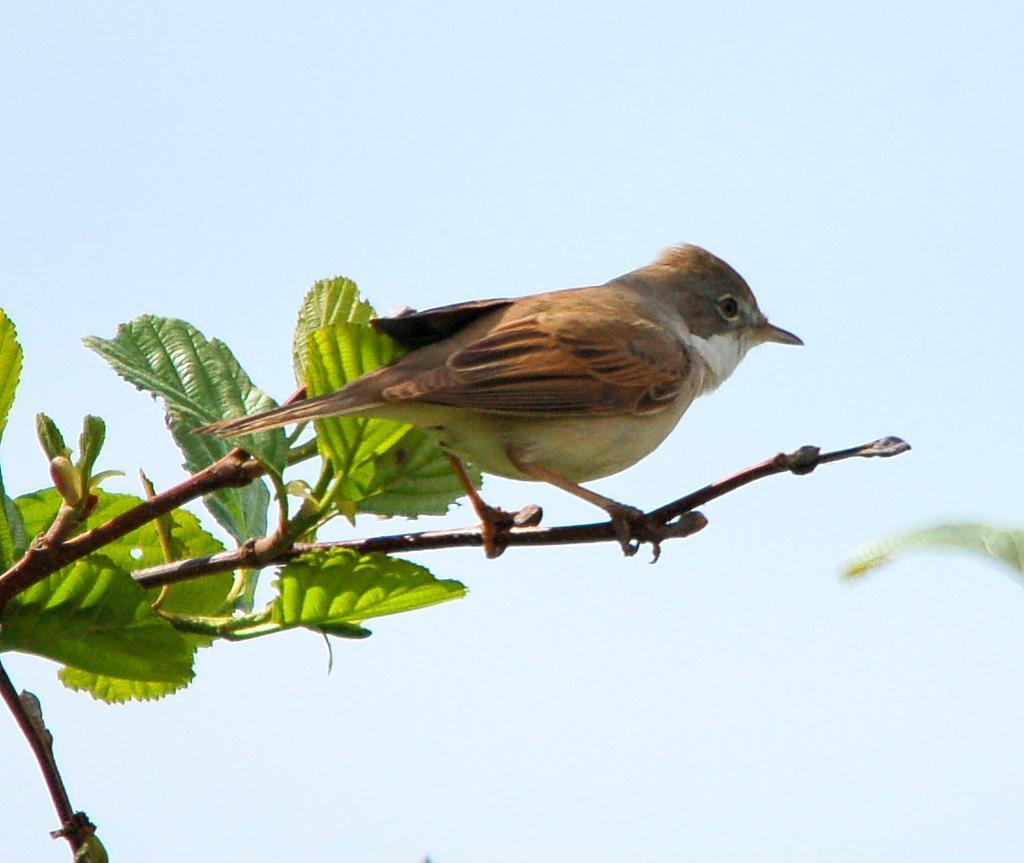How would you summarize this image in a sentence or two? In the center of the image a bird is present on stem. On the left side of the image we can see the leaves. In the background of the image we can see the sky. 